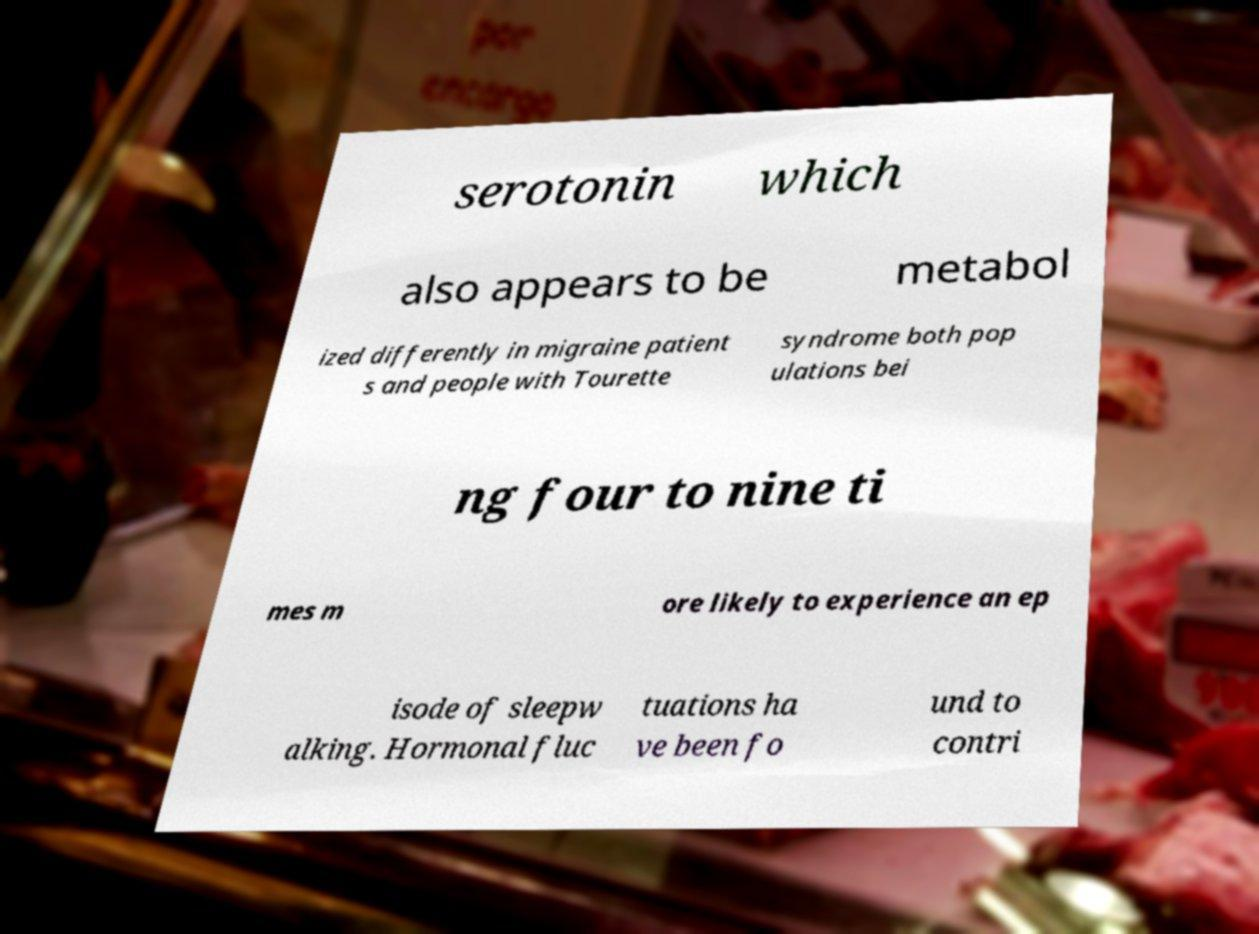For documentation purposes, I need the text within this image transcribed. Could you provide that? serotonin which also appears to be metabol ized differently in migraine patient s and people with Tourette syndrome both pop ulations bei ng four to nine ti mes m ore likely to experience an ep isode of sleepw alking. Hormonal fluc tuations ha ve been fo und to contri 